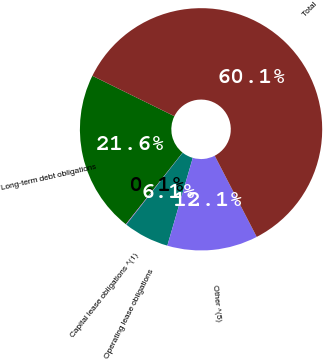Convert chart to OTSL. <chart><loc_0><loc_0><loc_500><loc_500><pie_chart><fcel>Long-term debt obligations<fcel>Capital lease obligations ^(1)<fcel>Operating lease obligations<fcel>Other ^(5)<fcel>Total<nl><fcel>21.62%<fcel>0.08%<fcel>6.09%<fcel>12.09%<fcel>60.12%<nl></chart> 